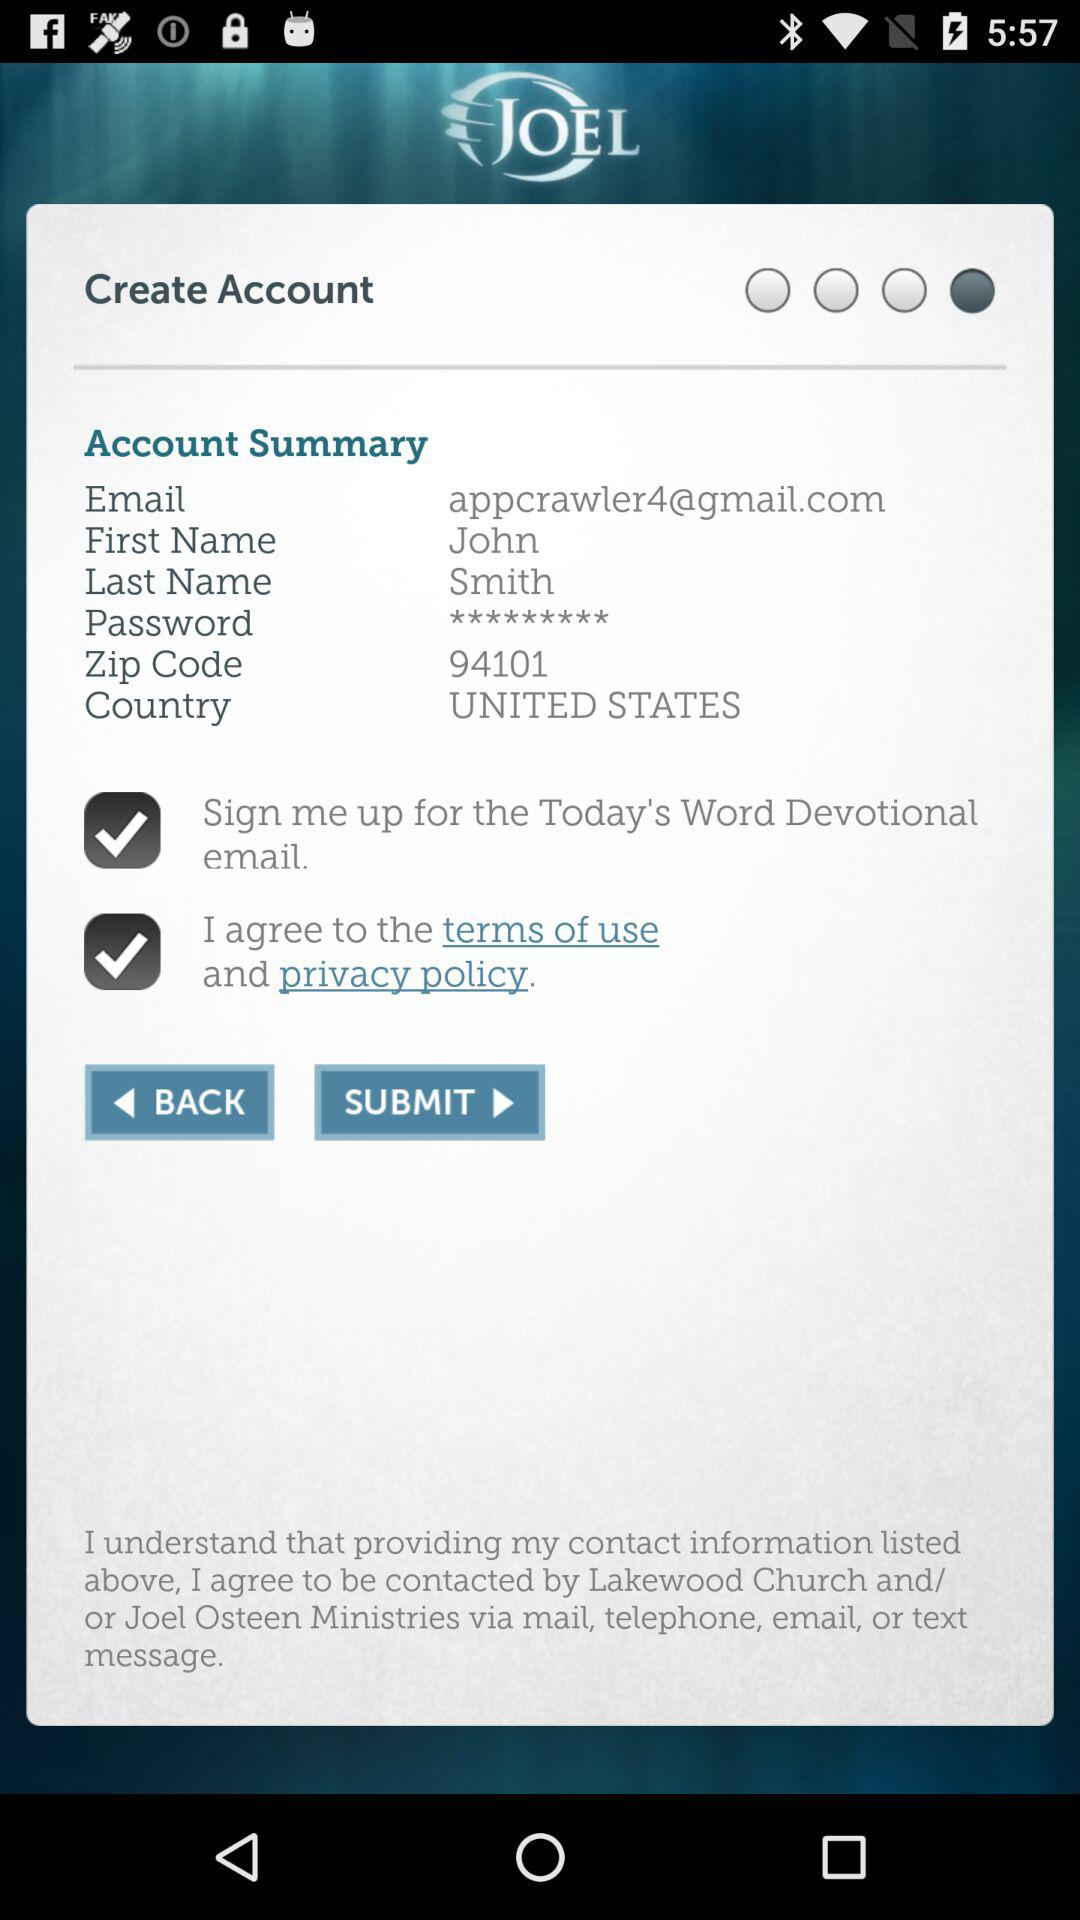What is the first name? The first name is John. 